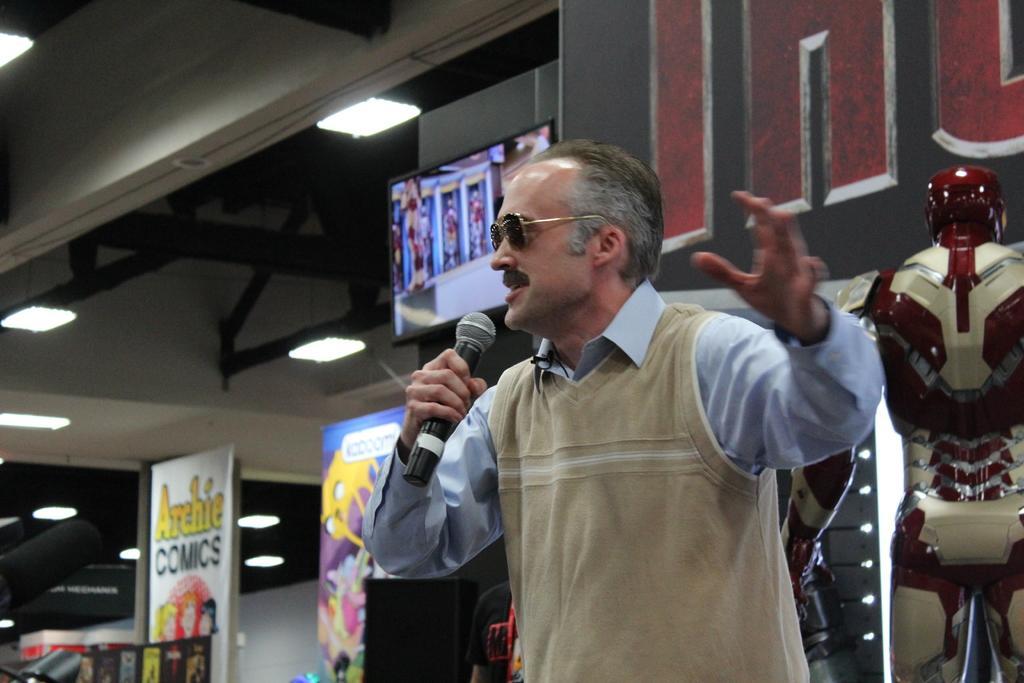In one or two sentences, can you explain what this image depicts? In the center of the image we can see a man wearing the glasses and holding the mike. In the background we can see the banners, sound box and also the depiction of a person on the right. We can also see the wall, lights, some rods and also the ceiling. 